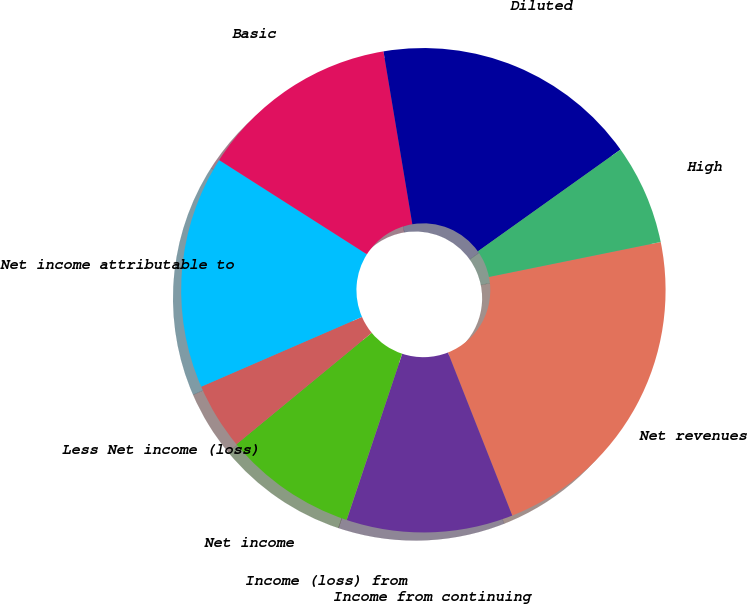<chart> <loc_0><loc_0><loc_500><loc_500><pie_chart><fcel>Net revenues<fcel>Income from continuing<fcel>Income (loss) from<fcel>Net income<fcel>Less Net income (loss)<fcel>Net income attributable to<fcel>Basic<fcel>Diluted<fcel>High<nl><fcel>22.21%<fcel>11.11%<fcel>0.01%<fcel>8.89%<fcel>4.45%<fcel>15.55%<fcel>13.33%<fcel>17.77%<fcel>6.67%<nl></chart> 